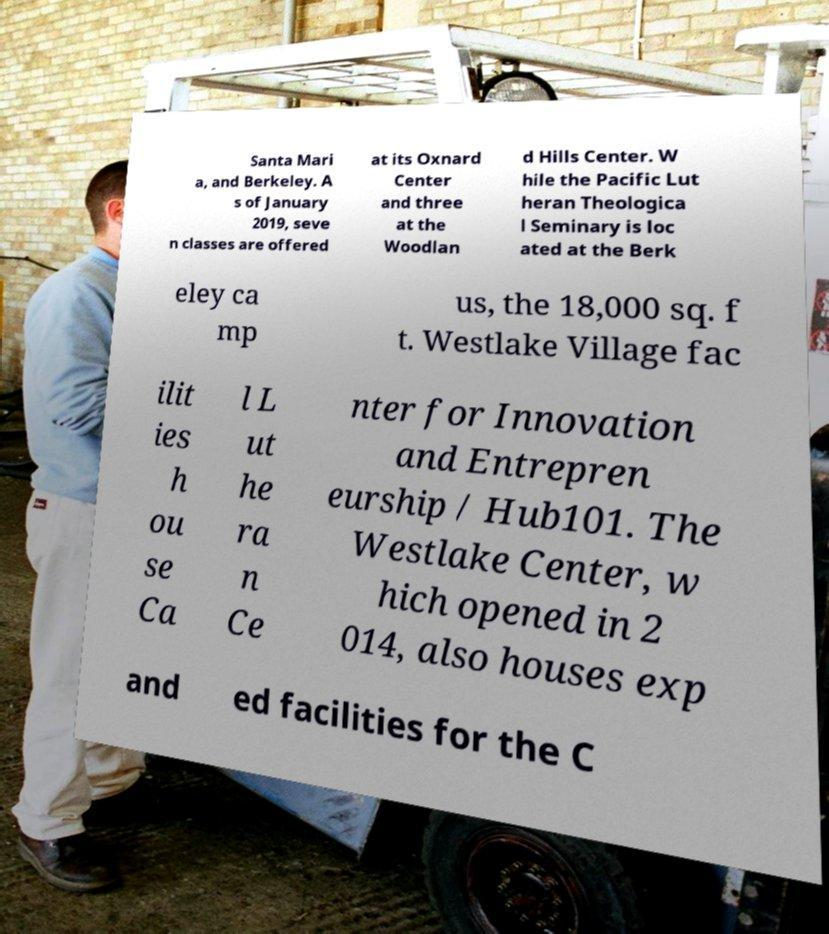Can you read and provide the text displayed in the image?This photo seems to have some interesting text. Can you extract and type it out for me? Santa Mari a, and Berkeley. A s of January 2019, seve n classes are offered at its Oxnard Center and three at the Woodlan d Hills Center. W hile the Pacific Lut heran Theologica l Seminary is loc ated at the Berk eley ca mp us, the 18,000 sq. f t. Westlake Village fac ilit ies h ou se Ca l L ut he ra n Ce nter for Innovation and Entrepren eurship / Hub101. The Westlake Center, w hich opened in 2 014, also houses exp and ed facilities for the C 